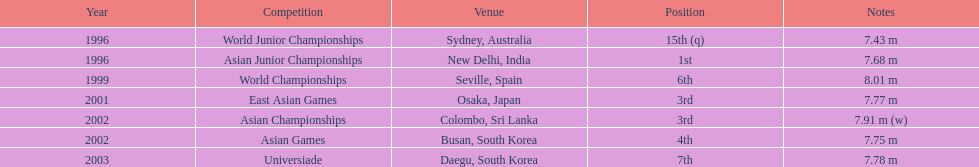What is the difference between the frequency of achieving third place and the frequency of achieving first place? 1. 